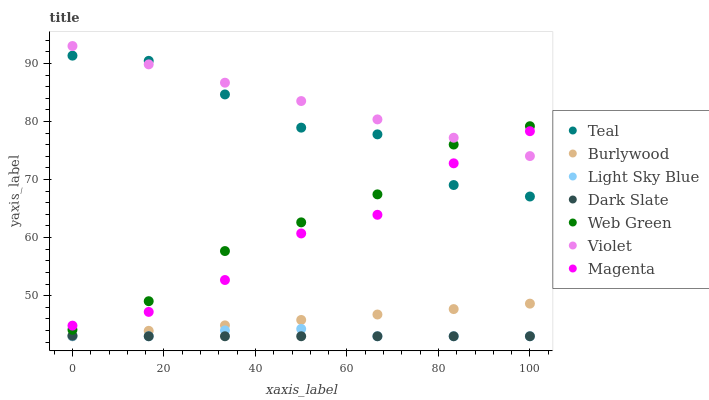Does Dark Slate have the minimum area under the curve?
Answer yes or no. Yes. Does Violet have the maximum area under the curve?
Answer yes or no. Yes. Does Web Green have the minimum area under the curve?
Answer yes or no. No. Does Web Green have the maximum area under the curve?
Answer yes or no. No. Is Burlywood the smoothest?
Answer yes or no. Yes. Is Teal the roughest?
Answer yes or no. Yes. Is Web Green the smoothest?
Answer yes or no. No. Is Web Green the roughest?
Answer yes or no. No. Does Burlywood have the lowest value?
Answer yes or no. Yes. Does Web Green have the lowest value?
Answer yes or no. No. Does Violet have the highest value?
Answer yes or no. Yes. Does Web Green have the highest value?
Answer yes or no. No. Is Dark Slate less than Teal?
Answer yes or no. Yes. Is Web Green greater than Burlywood?
Answer yes or no. Yes. Does Web Green intersect Magenta?
Answer yes or no. Yes. Is Web Green less than Magenta?
Answer yes or no. No. Is Web Green greater than Magenta?
Answer yes or no. No. Does Dark Slate intersect Teal?
Answer yes or no. No. 